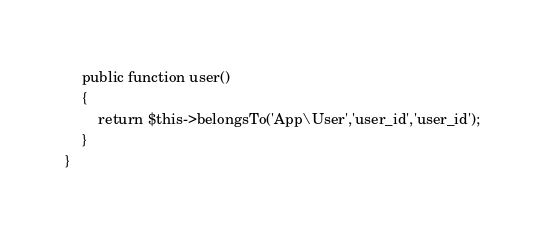Convert code to text. <code><loc_0><loc_0><loc_500><loc_500><_PHP_>    public function user() 
    {
    	return $this->belongsTo('App\User','user_id','user_id');
    }
}
</code> 